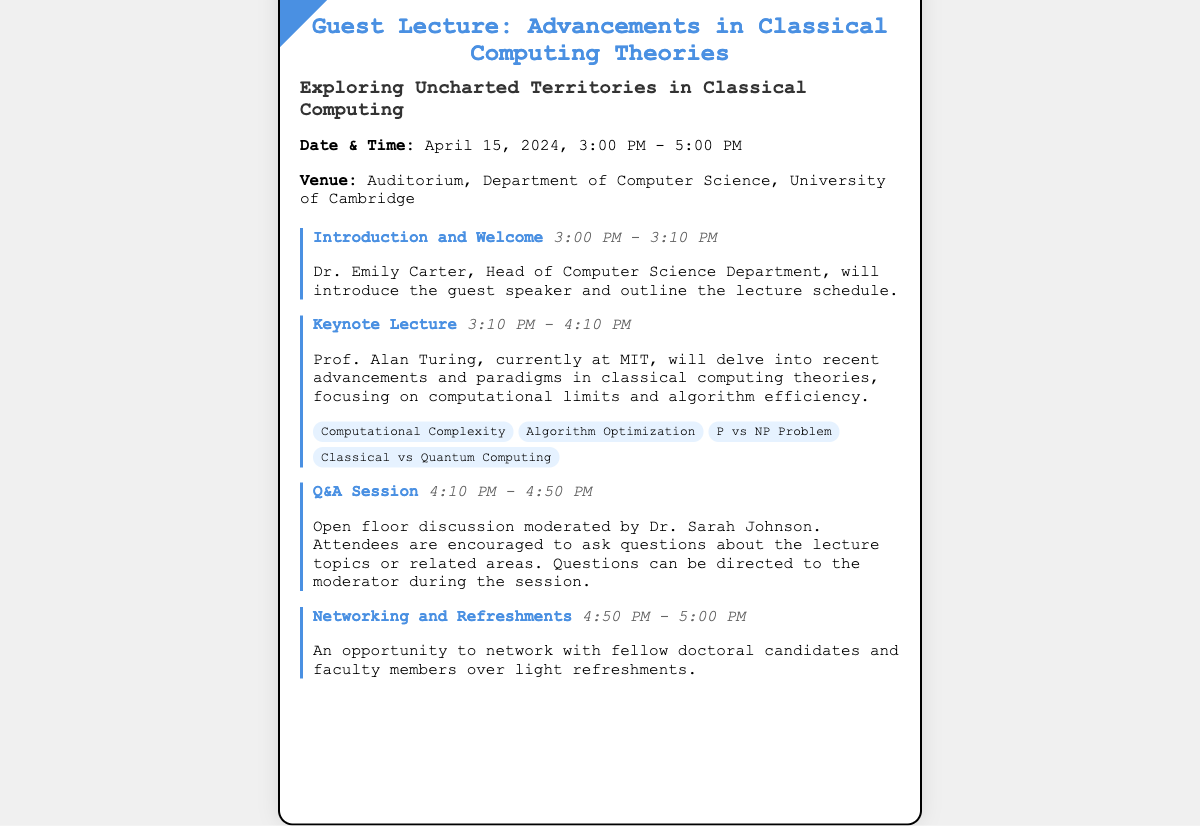What is the lecture's topic? The topic of the lecture is found in the title and subtitle of the ticket.
Answer: Advancements in Classical Computing Theories Who is the guest speaker? The guest speaker is identified in the event schedule for the keynote lecture.
Answer: Prof. Alan Turing What is the date of the event? The date of the event is specified in the details section of the ticket.
Answer: April 15, 2024 What time does the Q&A session start? The start time for the Q&A session is indicated in the corresponding event section.
Answer: 4:10 PM How long is the keynote lecture? The duration of the keynote lecture can be determined by the time range provided for that event.
Answer: 1 hour Who will moderate the Q&A session? The moderator for the Q&A session is mentioned in the event description.
Answer: Dr. Sarah Johnson What are the sub-topics of the keynote lecture? The sub-topics are listed under the keynote lecture description.
Answer: Computational Complexity, Algorithm Optimization, P vs NP Problem, Classical vs Quantum Computing What is the venue of the lecture? The venue is mentioned in the details section of the ticket.
Answer: Auditorium, Department of Computer Science, University of Cambridge What time is the networking session? The timing for the networking session is included at the end of the event schedule.
Answer: 4:50 PM - 5:00 PM 